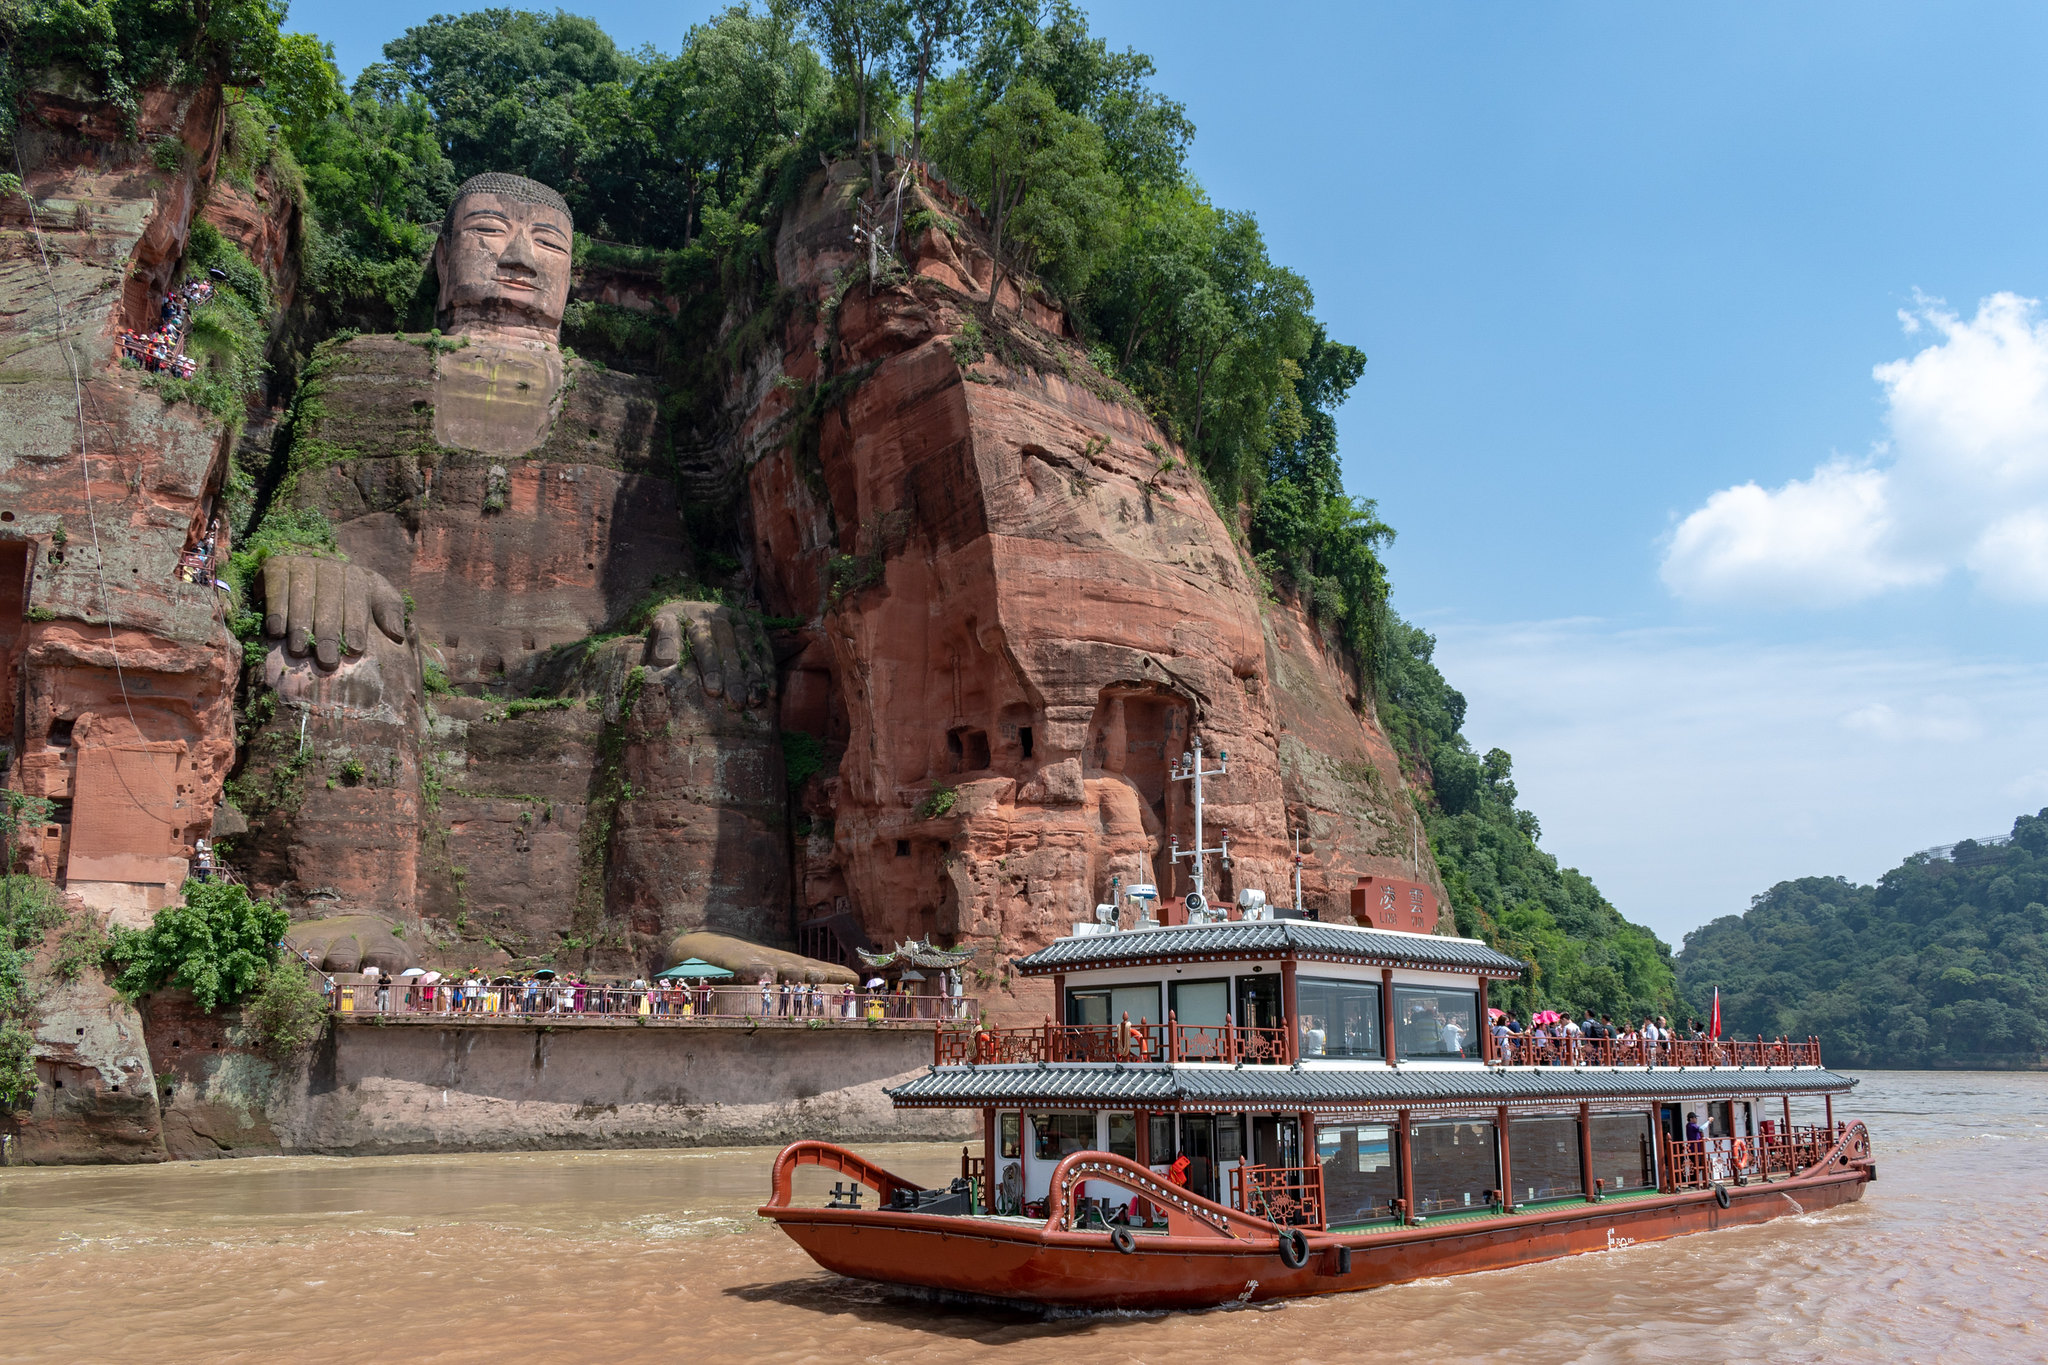What would a photo emphasizing the boat over the statue look like? A photograph emphasizing the boat over the statue would highlight the vessel’s intricate details, vivid colors, and cultural elements. The boat, adorned with traditional Chinese designs, would be the focal point, with the camera angle capturing its vibrant red and white tones against the backdrop of the water. The statue of the Leshan Giant Buddha would be visible in the background but slightly out of focus, creating a sense of depth and context without overshadowing the boat. This perspective would celebrate the cultural craftsmanship of the boat, offering a fresh and dynamic viewpoint within the larger scene. What would it be like if the cliff face suddenly transformed into a giant animated Buddha that began to speak? Imagine the cliff face tingling with a mystic aura, the stone surface rippling as if waking from a centuries-long slumber. The colossal Buddha's eyes slowly blink open, radiating warmth and wisdom. An ancient, mellow voice resonates through the valley, speaking in an archaic tongue that somehow you understand. The trees and grass react, swaying gently to the rhythm of the Buddha’s speech, while the river starts to glow a soft luminescent blue, reflecting the divine energy now permeating the surroundings. Visitors look on in awe and reverence, participating in a once-in-a-lifetime communion with what seems to be a guardian of nature and history. This surreal spectacle blurs the line between myth and reality, leaving an indelible impression on every witness. 